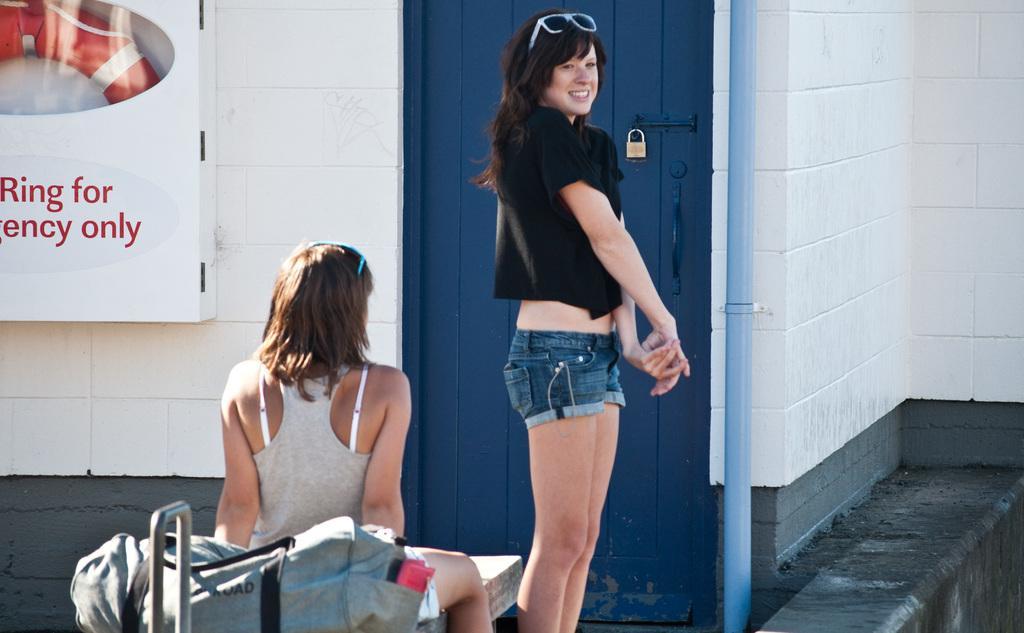Could you give a brief overview of what you see in this image? In this picture we can observe two women. One of the women was standing wearing black color dress and spectacles on her head. She is smiling and the other woman was sitting on the bench. Behind her there is a bag which is in grey color. In the background we can observe blue color door and white color poster fixed to the white color wall. 